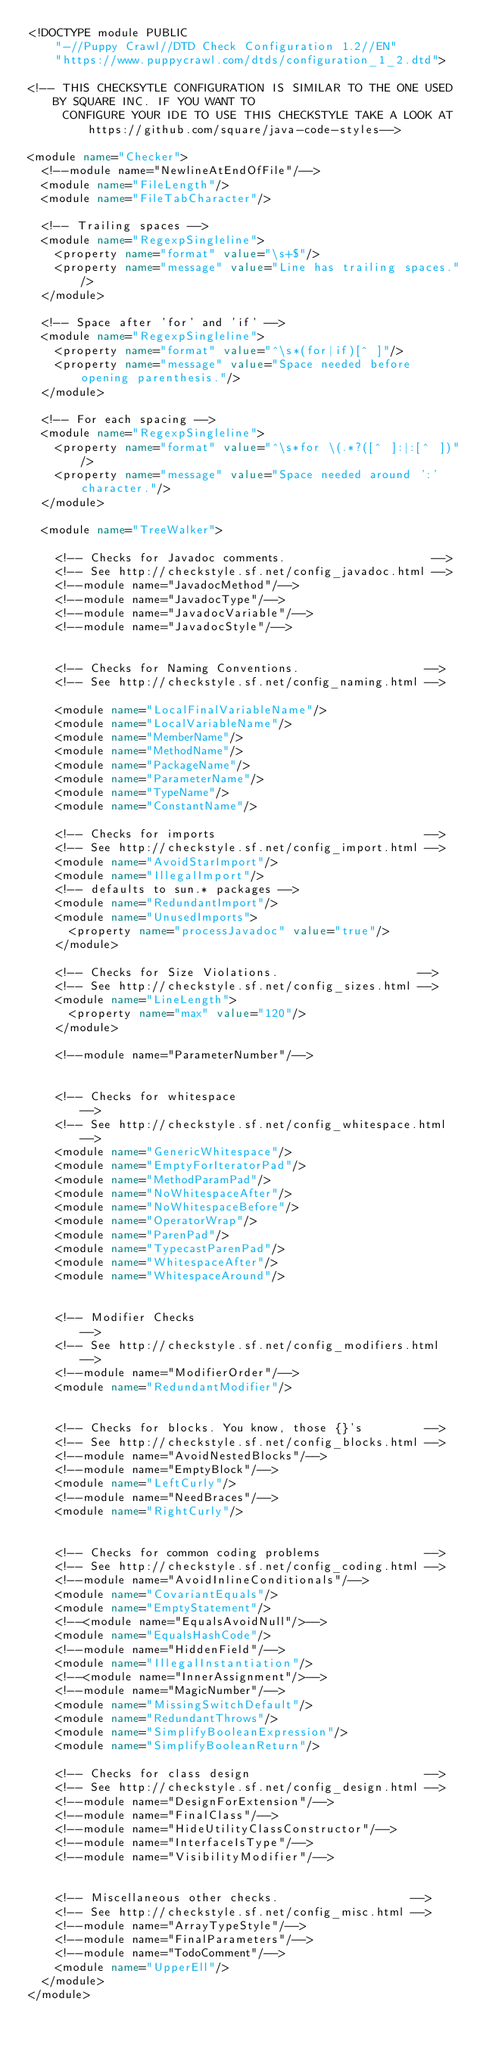<code> <loc_0><loc_0><loc_500><loc_500><_XML_><!DOCTYPE module PUBLIC
    "-//Puppy Crawl//DTD Check Configuration 1.2//EN"
    "https://www.puppycrawl.com/dtds/configuration_1_2.dtd">

<!-- THIS CHECKSYTLE CONFIGURATION IS SIMILAR TO THE ONE USED BY SQUARE INC. IF YOU WANT TO
     CONFIGURE YOUR IDE TO USE THIS CHECKSTYLE TAKE A LOOK AT https://github.com/square/java-code-styles-->

<module name="Checker">
  <!--module name="NewlineAtEndOfFile"/-->
  <module name="FileLength"/>
  <module name="FileTabCharacter"/>

  <!-- Trailing spaces -->
  <module name="RegexpSingleline">
    <property name="format" value="\s+$"/>
    <property name="message" value="Line has trailing spaces."/>
  </module>

  <!-- Space after 'for' and 'if' -->
  <module name="RegexpSingleline">
    <property name="format" value="^\s*(for|if)[^ ]"/>
    <property name="message" value="Space needed before opening parenthesis."/>
  </module>

  <!-- For each spacing -->
  <module name="RegexpSingleline">
    <property name="format" value="^\s*for \(.*?([^ ]:|:[^ ])"/>
    <property name="message" value="Space needed around ':' character."/>
  </module>

  <module name="TreeWalker">

    <!-- Checks for Javadoc comments.                     -->
    <!-- See http://checkstyle.sf.net/config_javadoc.html -->
    <!--module name="JavadocMethod"/-->
    <!--module name="JavadocType"/-->
    <!--module name="JavadocVariable"/-->
    <!--module name="JavadocStyle"/-->


    <!-- Checks for Naming Conventions.                  -->
    <!-- See http://checkstyle.sf.net/config_naming.html -->

    <module name="LocalFinalVariableName"/>
    <module name="LocalVariableName"/>
    <module name="MemberName"/>
    <module name="MethodName"/>
    <module name="PackageName"/>
    <module name="ParameterName"/>
    <module name="TypeName"/>
    <module name="ConstantName"/>

    <!-- Checks for imports                              -->
    <!-- See http://checkstyle.sf.net/config_import.html -->
    <module name="AvoidStarImport"/>
    <module name="IllegalImport"/>
    <!-- defaults to sun.* packages -->
    <module name="RedundantImport"/>
    <module name="UnusedImports">
      <property name="processJavadoc" value="true"/>
    </module>

    <!-- Checks for Size Violations.                    -->
    <!-- See http://checkstyle.sf.net/config_sizes.html -->
    <module name="LineLength">
      <property name="max" value="120"/>
    </module>

    <!--module name="ParameterNumber"/-->


    <!-- Checks for whitespace                               -->
    <!-- See http://checkstyle.sf.net/config_whitespace.html -->
    <module name="GenericWhitespace"/>
    <module name="EmptyForIteratorPad"/>
    <module name="MethodParamPad"/>
    <module name="NoWhitespaceAfter"/>
    <module name="NoWhitespaceBefore"/>
    <module name="OperatorWrap"/>
    <module name="ParenPad"/>
    <module name="TypecastParenPad"/>
    <module name="WhitespaceAfter"/>
    <module name="WhitespaceAround"/>


    <!-- Modifier Checks                                    -->
    <!-- See http://checkstyle.sf.net/config_modifiers.html -->
    <!--module name="ModifierOrder"/-->
    <module name="RedundantModifier"/>


    <!-- Checks for blocks. You know, those {}'s         -->
    <!-- See http://checkstyle.sf.net/config_blocks.html -->
    <!--module name="AvoidNestedBlocks"/-->
    <!--module name="EmptyBlock"/-->
    <module name="LeftCurly"/>
    <!--module name="NeedBraces"/-->
    <module name="RightCurly"/>


    <!-- Checks for common coding problems               -->
    <!-- See http://checkstyle.sf.net/config_coding.html -->
    <!--module name="AvoidInlineConditionals"/-->
    <module name="CovariantEquals"/>
    <module name="EmptyStatement"/>
    <!--<module name="EqualsAvoidNull"/>-->
    <module name="EqualsHashCode"/>
    <!--module name="HiddenField"/-->
    <module name="IllegalInstantiation"/>
    <!--<module name="InnerAssignment"/>-->
    <!--module name="MagicNumber"/-->
    <module name="MissingSwitchDefault"/>
    <module name="RedundantThrows"/>
    <module name="SimplifyBooleanExpression"/>
    <module name="SimplifyBooleanReturn"/>

    <!-- Checks for class design                         -->
    <!-- See http://checkstyle.sf.net/config_design.html -->
    <!--module name="DesignForExtension"/-->
    <!--module name="FinalClass"/-->
    <!--module name="HideUtilityClassConstructor"/-->
    <!--module name="InterfaceIsType"/-->
    <!--module name="VisibilityModifier"/-->


    <!-- Miscellaneous other checks.                   -->
    <!-- See http://checkstyle.sf.net/config_misc.html -->
    <!--module name="ArrayTypeStyle"/-->
    <!--module name="FinalParameters"/-->
    <!--module name="TodoComment"/-->
    <module name="UpperEll"/>
  </module>
</module></code> 